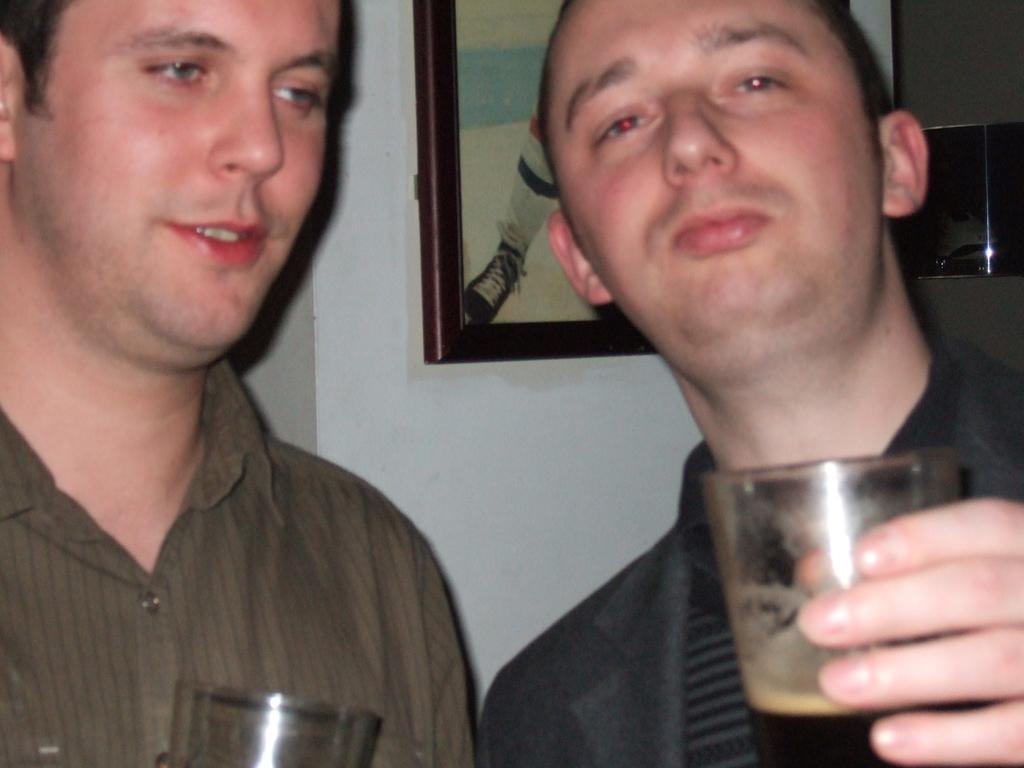What can be seen in the image? There are men standing in the image. What are the men holding in their hands? The men are holding juice glasses in their hands. Is there any decoration or object on the wall in the image? Yes, there is a photo frame on the wall in the image. How many tomatoes are on the table in the image? There are no tomatoes present in the image. Can you see any nests in the image? There are no nests visible in the image. 